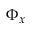<formula> <loc_0><loc_0><loc_500><loc_500>\Phi _ { x }</formula> 